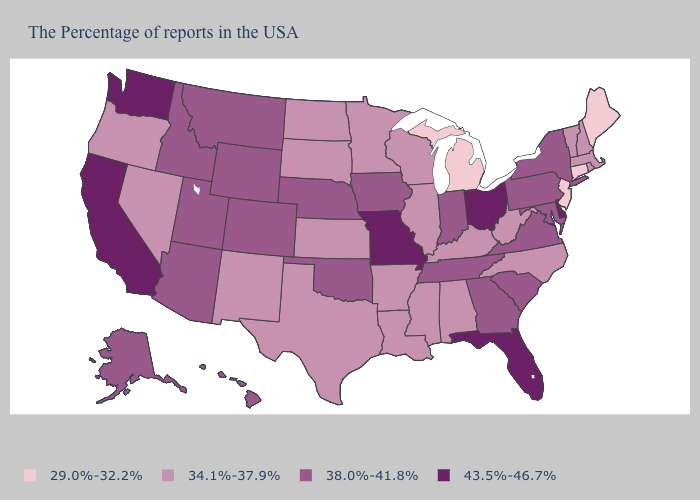Name the states that have a value in the range 43.5%-46.7%?
Give a very brief answer. Delaware, Ohio, Florida, Missouri, California, Washington. Does Michigan have the lowest value in the MidWest?
Short answer required. Yes. Is the legend a continuous bar?
Answer briefly. No. What is the value of Texas?
Short answer required. 34.1%-37.9%. Does Wyoming have a higher value than Tennessee?
Give a very brief answer. No. What is the lowest value in the Northeast?
Be succinct. 29.0%-32.2%. Does Virginia have the highest value in the USA?
Write a very short answer. No. Does South Dakota have a higher value than Minnesota?
Be succinct. No. Does North Dakota have the lowest value in the USA?
Keep it brief. No. Does Hawaii have a lower value than Missouri?
Short answer required. Yes. Does Washington have the highest value in the West?
Answer briefly. Yes. Does Hawaii have a higher value than West Virginia?
Short answer required. Yes. Which states hav the highest value in the West?
Answer briefly. California, Washington. Name the states that have a value in the range 38.0%-41.8%?
Short answer required. New York, Maryland, Pennsylvania, Virginia, South Carolina, Georgia, Indiana, Tennessee, Iowa, Nebraska, Oklahoma, Wyoming, Colorado, Utah, Montana, Arizona, Idaho, Alaska, Hawaii. Which states have the lowest value in the USA?
Keep it brief. Maine, Connecticut, New Jersey, Michigan. 